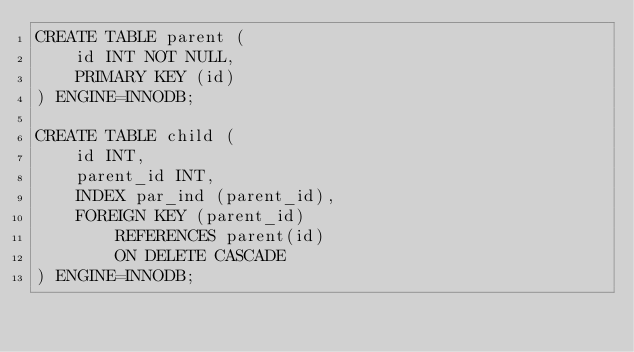<code> <loc_0><loc_0><loc_500><loc_500><_SQL_>CREATE TABLE parent (
    id INT NOT NULL,
    PRIMARY KEY (id)
) ENGINE=INNODB;

CREATE TABLE child (
    id INT,
    parent_id INT,
    INDEX par_ind (parent_id),
    FOREIGN KEY (parent_id)
        REFERENCES parent(id)
        ON DELETE CASCADE
) ENGINE=INNODB;</code> 